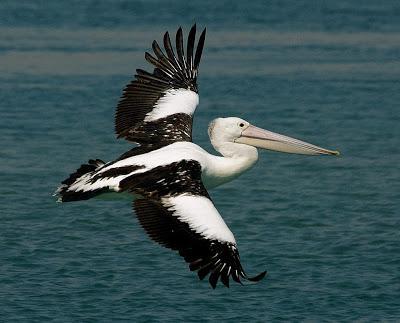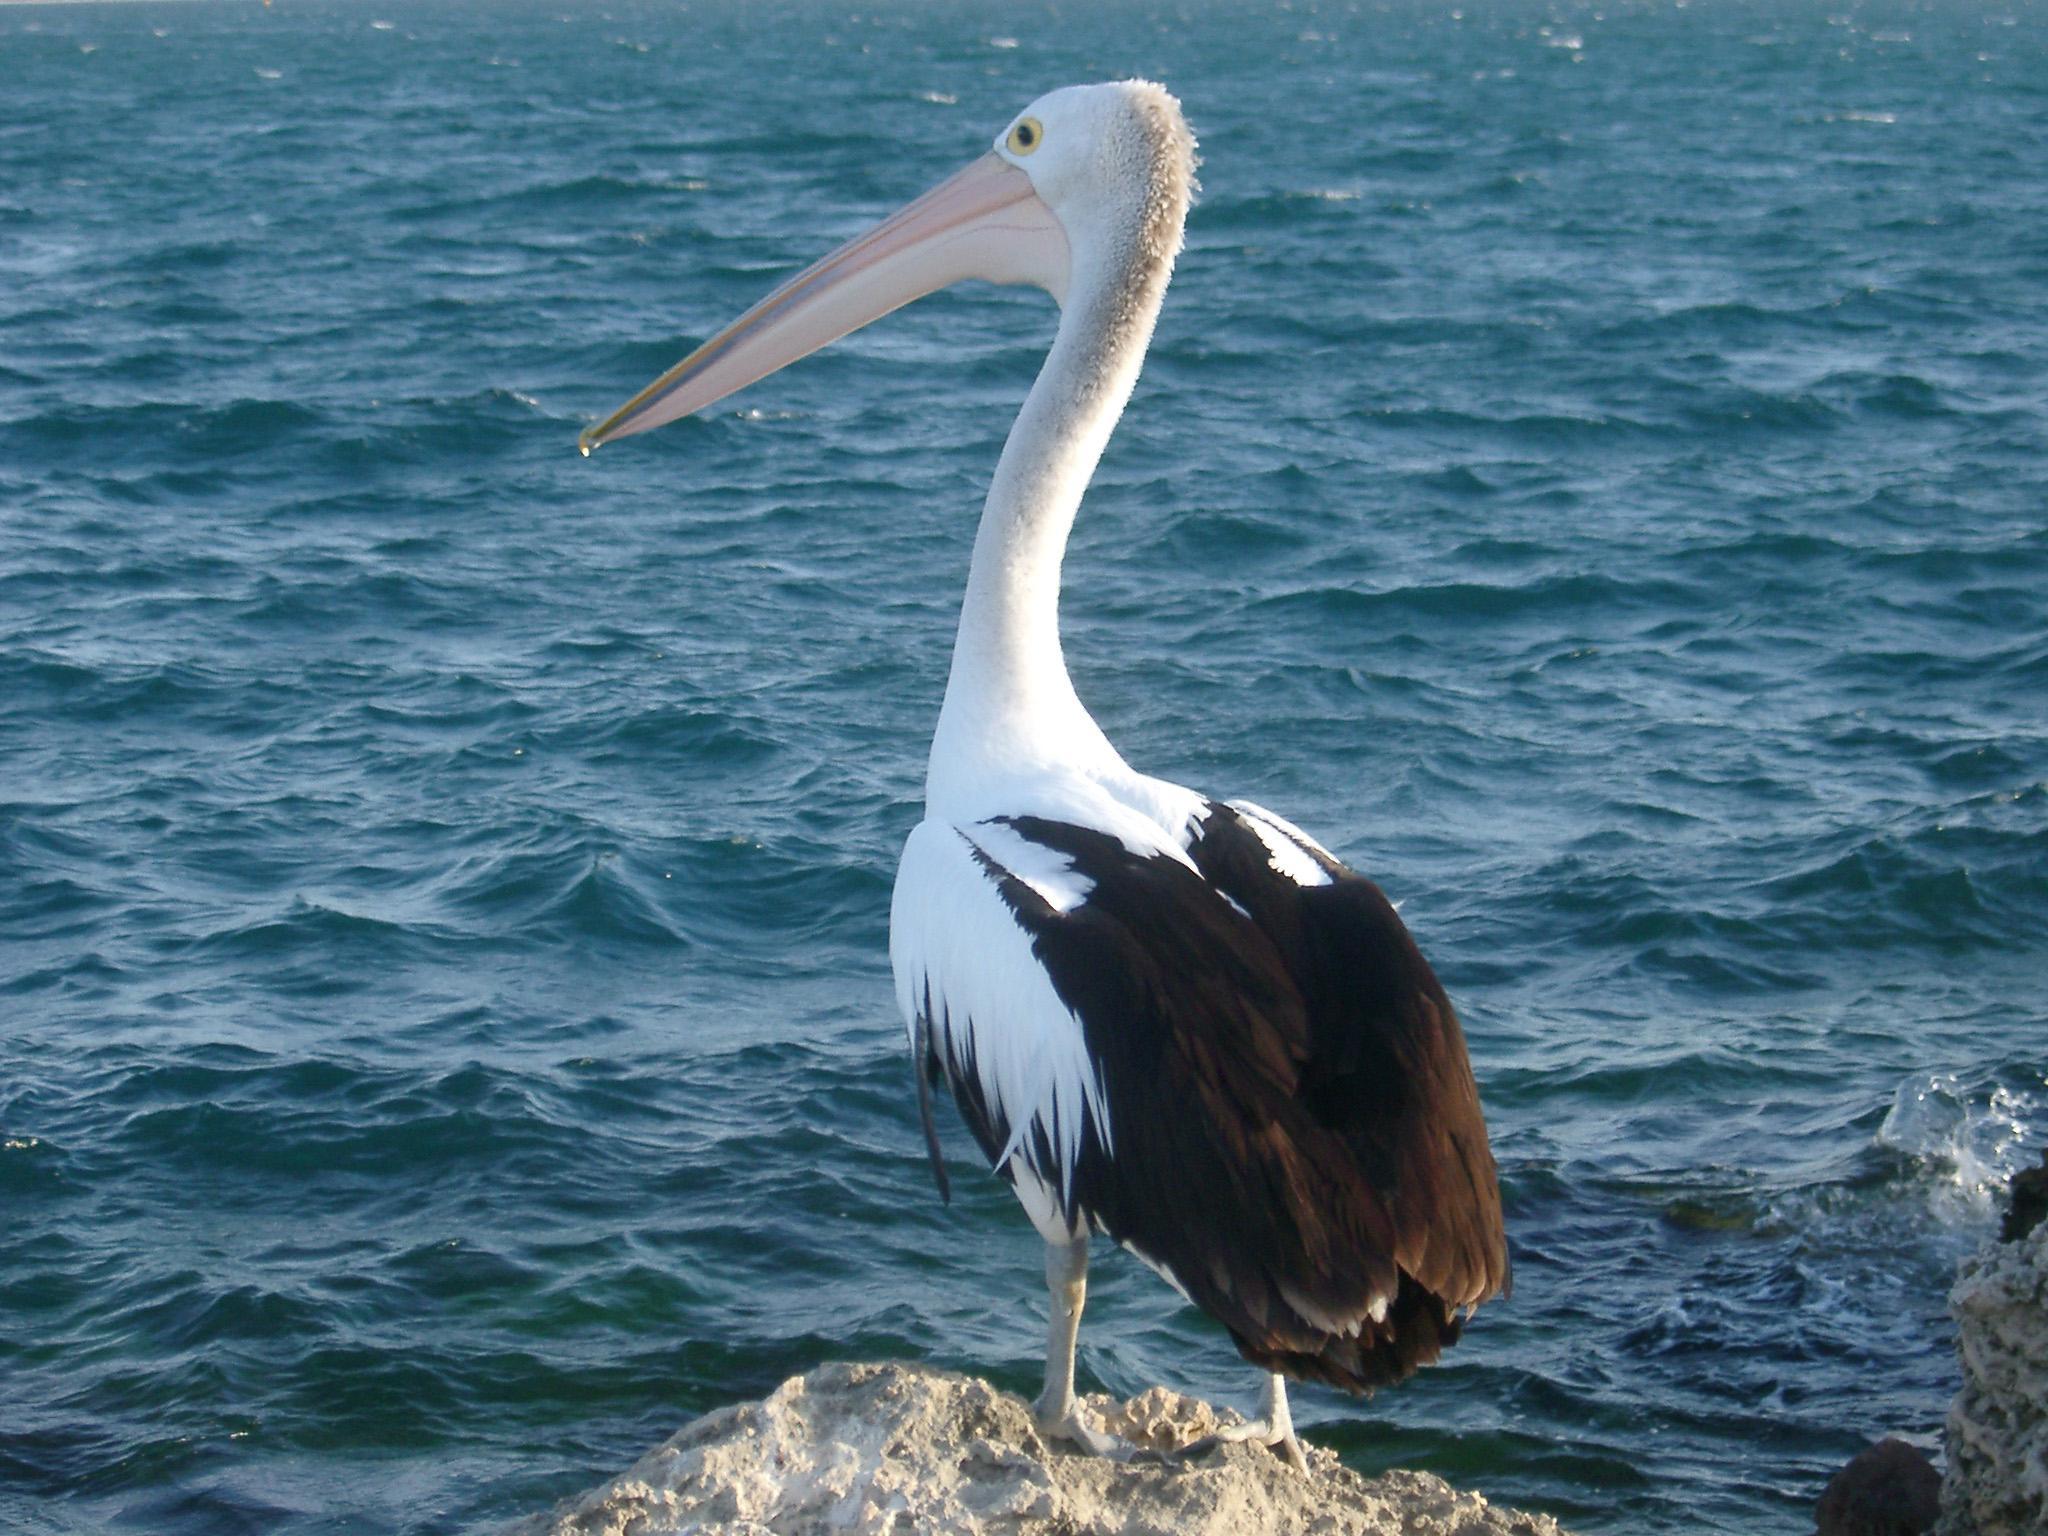The first image is the image on the left, the second image is the image on the right. For the images displayed, is the sentence "One image shows a pelican in flight." factually correct? Answer yes or no. Yes. 